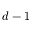Convert formula to latex. <formula><loc_0><loc_0><loc_500><loc_500>d - 1</formula> 